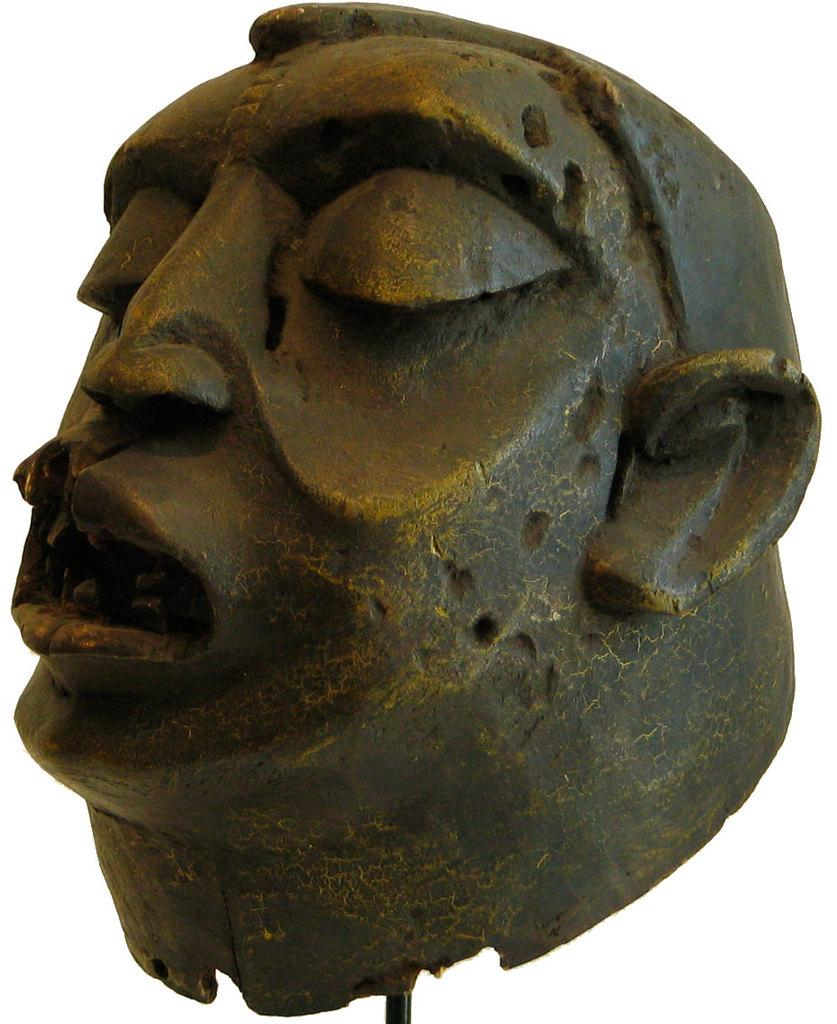What is the main subject of the image? There is a sculpture in the image. How many cacti can be seen on the slope in the image? There are no cacti or slopes present in the image; it features a sculpture. 